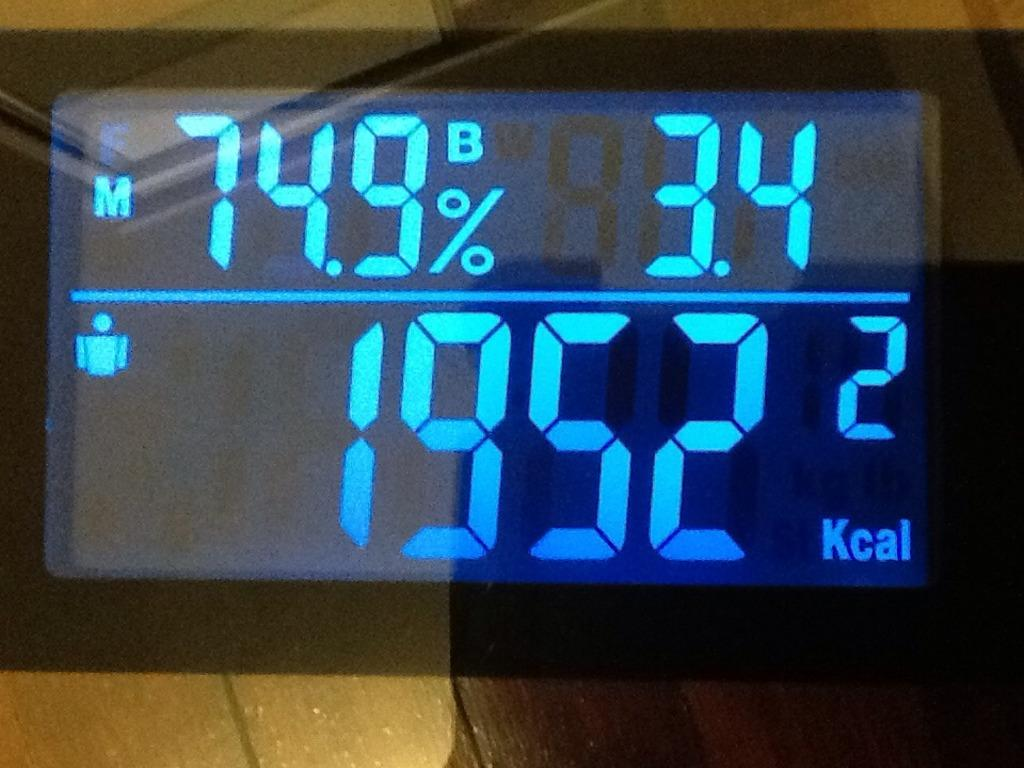<image>
Render a clear and concise summary of the photo. A display with the percent 74.9% on it 